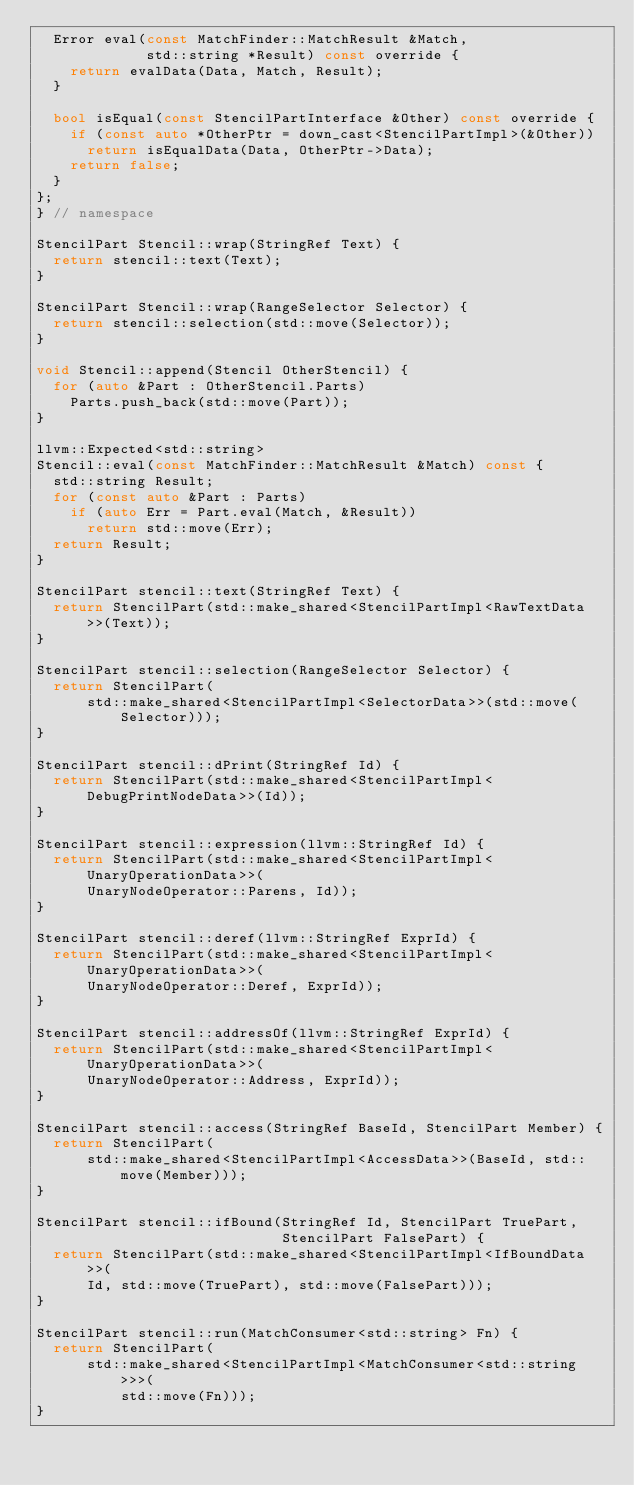Convert code to text. <code><loc_0><loc_0><loc_500><loc_500><_C++_>  Error eval(const MatchFinder::MatchResult &Match,
             std::string *Result) const override {
    return evalData(Data, Match, Result);
  }

  bool isEqual(const StencilPartInterface &Other) const override {
    if (const auto *OtherPtr = down_cast<StencilPartImpl>(&Other))
      return isEqualData(Data, OtherPtr->Data);
    return false;
  }
};
} // namespace

StencilPart Stencil::wrap(StringRef Text) {
  return stencil::text(Text);
}

StencilPart Stencil::wrap(RangeSelector Selector) {
  return stencil::selection(std::move(Selector));
}

void Stencil::append(Stencil OtherStencil) {
  for (auto &Part : OtherStencil.Parts)
    Parts.push_back(std::move(Part));
}

llvm::Expected<std::string>
Stencil::eval(const MatchFinder::MatchResult &Match) const {
  std::string Result;
  for (const auto &Part : Parts)
    if (auto Err = Part.eval(Match, &Result))
      return std::move(Err);
  return Result;
}

StencilPart stencil::text(StringRef Text) {
  return StencilPart(std::make_shared<StencilPartImpl<RawTextData>>(Text));
}

StencilPart stencil::selection(RangeSelector Selector) {
  return StencilPart(
      std::make_shared<StencilPartImpl<SelectorData>>(std::move(Selector)));
}

StencilPart stencil::dPrint(StringRef Id) {
  return StencilPart(std::make_shared<StencilPartImpl<DebugPrintNodeData>>(Id));
}

StencilPart stencil::expression(llvm::StringRef Id) {
  return StencilPart(std::make_shared<StencilPartImpl<UnaryOperationData>>(
      UnaryNodeOperator::Parens, Id));
}

StencilPart stencil::deref(llvm::StringRef ExprId) {
  return StencilPart(std::make_shared<StencilPartImpl<UnaryOperationData>>(
      UnaryNodeOperator::Deref, ExprId));
}

StencilPart stencil::addressOf(llvm::StringRef ExprId) {
  return StencilPart(std::make_shared<StencilPartImpl<UnaryOperationData>>(
      UnaryNodeOperator::Address, ExprId));
}

StencilPart stencil::access(StringRef BaseId, StencilPart Member) {
  return StencilPart(
      std::make_shared<StencilPartImpl<AccessData>>(BaseId, std::move(Member)));
}

StencilPart stencil::ifBound(StringRef Id, StencilPart TruePart,
                             StencilPart FalsePart) {
  return StencilPart(std::make_shared<StencilPartImpl<IfBoundData>>(
      Id, std::move(TruePart), std::move(FalsePart)));
}

StencilPart stencil::run(MatchConsumer<std::string> Fn) {
  return StencilPart(
      std::make_shared<StencilPartImpl<MatchConsumer<std::string>>>(
          std::move(Fn)));
}
</code> 